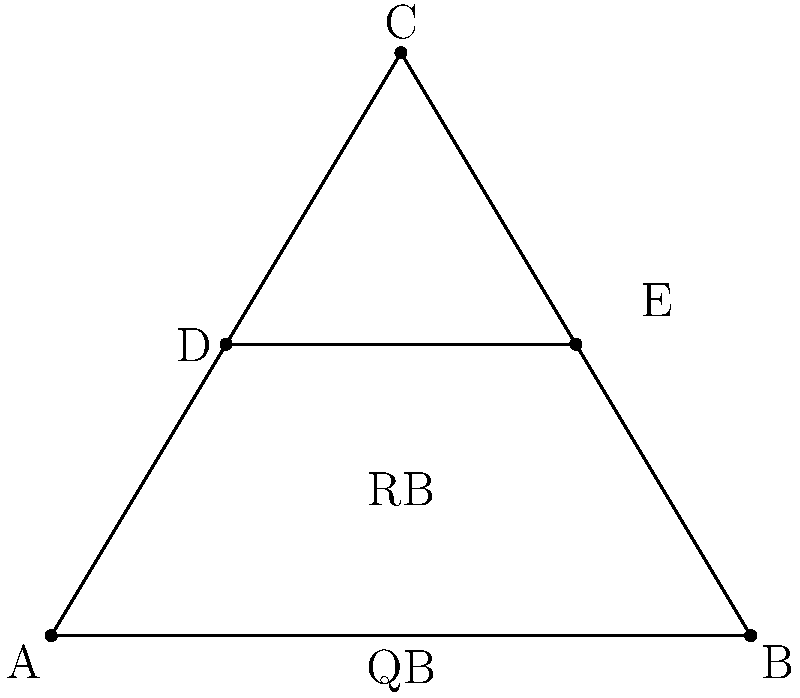In a new offensive formation, you've positioned your players in a triangle with the quarterback (QB) at the midpoint of the base and the running back (RB) directly above. If the triangle has a base of 6 yards and a height of 5 yards, and the RB is positioned on a line parallel to the base at a height of 2.5 yards, what is the distance between the QB and RB? Let's approach this step-by-step:

1) The triangle formed by the players is ABC, with QB at the midpoint of AB.

2) The base of the triangle (AB) is 6 yards, and the height (from C to AB) is 5 yards.

3) The RB is positioned on line DE, which is parallel to AB and 2.5 yards above it.

4) We need to find the distance between QB and RB.

5) The QB is at point (3,0) since it's at the midpoint of AB.

6) The RB is directly above QB at (3,2.5).

7) To find the distance between these two points, we can use the distance formula:
   $$d = \sqrt{(x_2-x_1)^2 + (y_2-y_1)^2}$$

8) Plugging in our values:
   $$d = \sqrt{(3-3)^2 + (2.5-0)^2}$$

9) Simplifying:
   $$d = \sqrt{0^2 + 2.5^2} = \sqrt{6.25} = 2.5$$

Therefore, the distance between the QB and RB is 2.5 yards.
Answer: 2.5 yards 